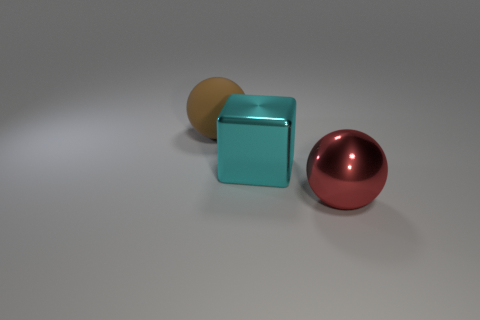How many other things are there of the same shape as the cyan metal object?
Give a very brief answer. 0. Does the big ball in front of the big matte object have the same color as the metallic object behind the big red thing?
Give a very brief answer. No. What is the size of the ball right of the sphere behind the metallic thing behind the big metal ball?
Your answer should be very brief. Large. There is a large object that is right of the big brown thing and on the left side of the big metal ball; what is its shape?
Ensure brevity in your answer.  Cube. Is the number of cyan shiny objects left of the red object the same as the number of cyan metal cubes behind the cyan block?
Offer a very short reply. No. Is there a big brown object made of the same material as the big red sphere?
Make the answer very short. No. Is the material of the large brown sphere behind the big cyan cube the same as the large block?
Provide a succinct answer. No. There is a object that is both to the right of the large brown rubber object and behind the red thing; what size is it?
Offer a terse response. Large. The big rubber ball is what color?
Keep it short and to the point. Brown. How many brown cylinders are there?
Your answer should be very brief. 0. 